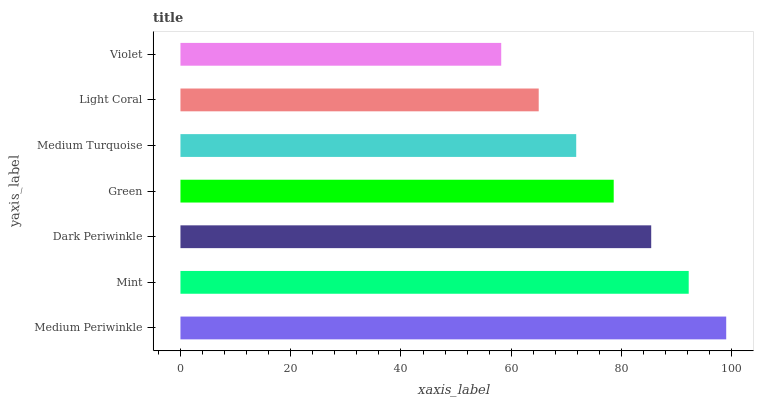Is Violet the minimum?
Answer yes or no. Yes. Is Medium Periwinkle the maximum?
Answer yes or no. Yes. Is Mint the minimum?
Answer yes or no. No. Is Mint the maximum?
Answer yes or no. No. Is Medium Periwinkle greater than Mint?
Answer yes or no. Yes. Is Mint less than Medium Periwinkle?
Answer yes or no. Yes. Is Mint greater than Medium Periwinkle?
Answer yes or no. No. Is Medium Periwinkle less than Mint?
Answer yes or no. No. Is Green the high median?
Answer yes or no. Yes. Is Green the low median?
Answer yes or no. Yes. Is Mint the high median?
Answer yes or no. No. Is Violet the low median?
Answer yes or no. No. 